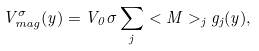<formula> <loc_0><loc_0><loc_500><loc_500>V _ { m a g } ^ { \sigma } ( y ) = V _ { 0 } \sigma \sum _ { j } < M > _ { j } g _ { j } ( y ) ,</formula> 